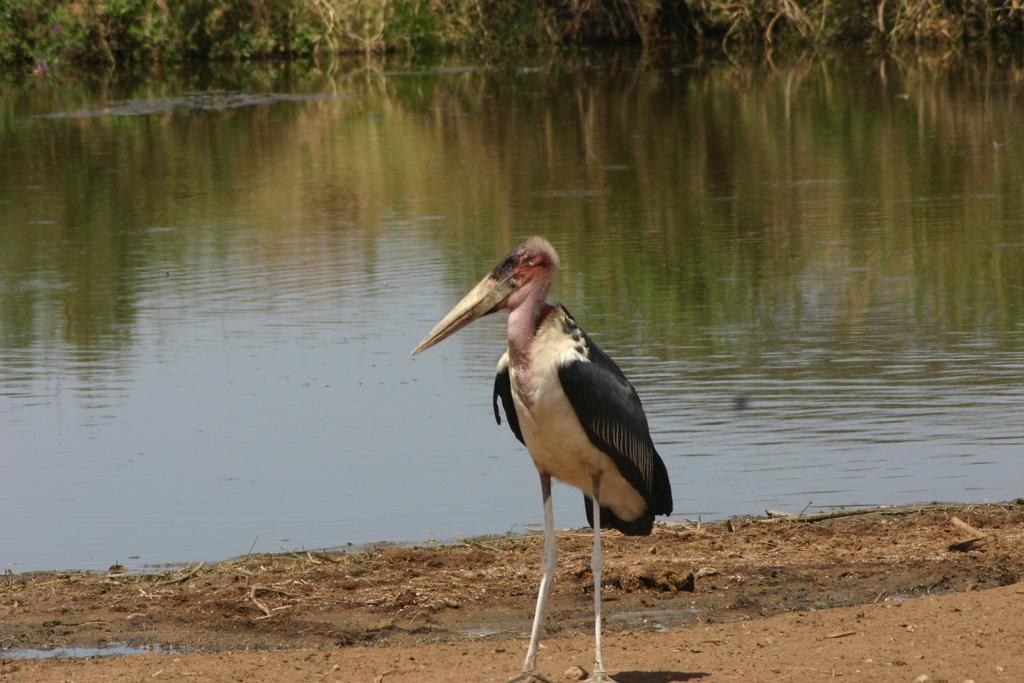In one or two sentences, can you explain what this image depicts? In this picture I can observe a crane standing on the land which is in white and black color. In the background I can observe a pond. 